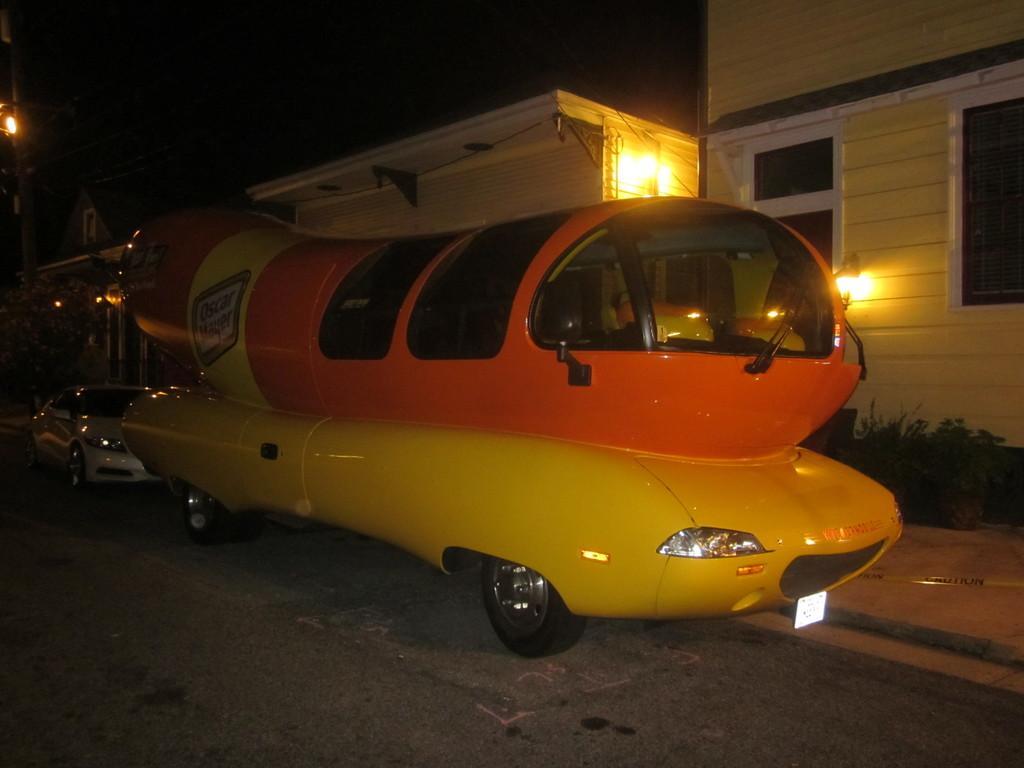Could you give a brief overview of what you see in this image? In this picture I can see a car and another vehicle on the road and I can see few buildings and I can see lights and plants. 